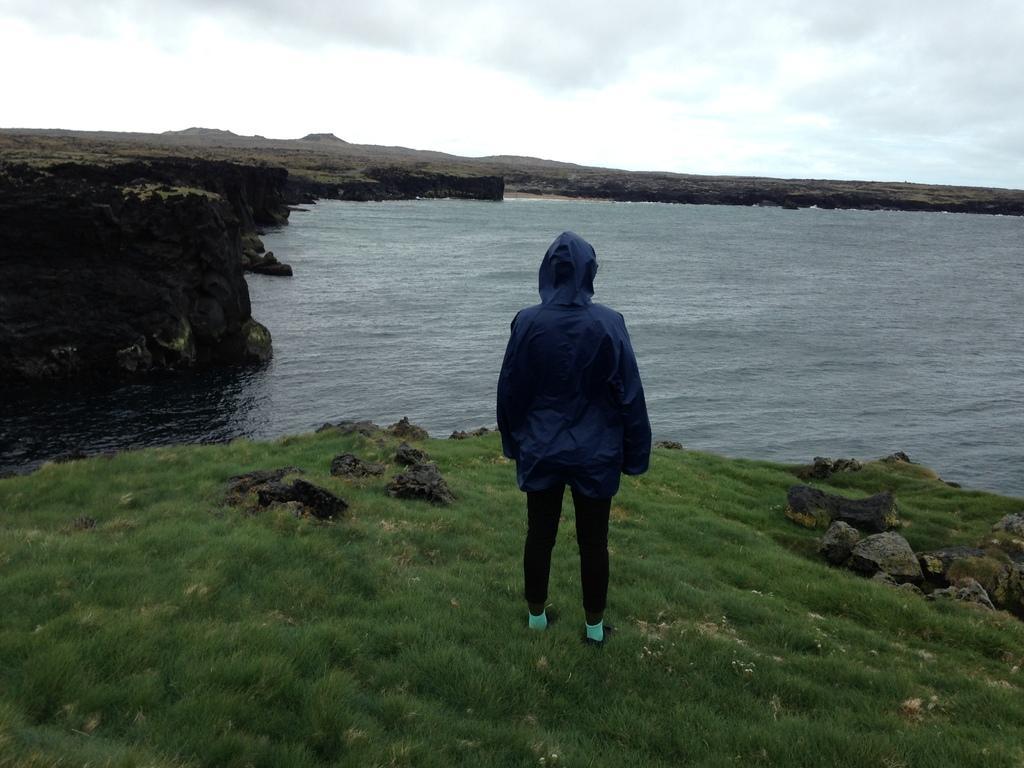How would you summarize this image in a sentence or two? In this image we can see a person is standing on the grass and we can see stones on the grass on the ground. In the background we can see water, cliff and clouds in the sky. 